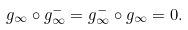<formula> <loc_0><loc_0><loc_500><loc_500>g _ { \infty } \circ g ^ { - } _ { \infty } = g ^ { - } _ { \infty } \circ g _ { \infty } = 0 .</formula> 